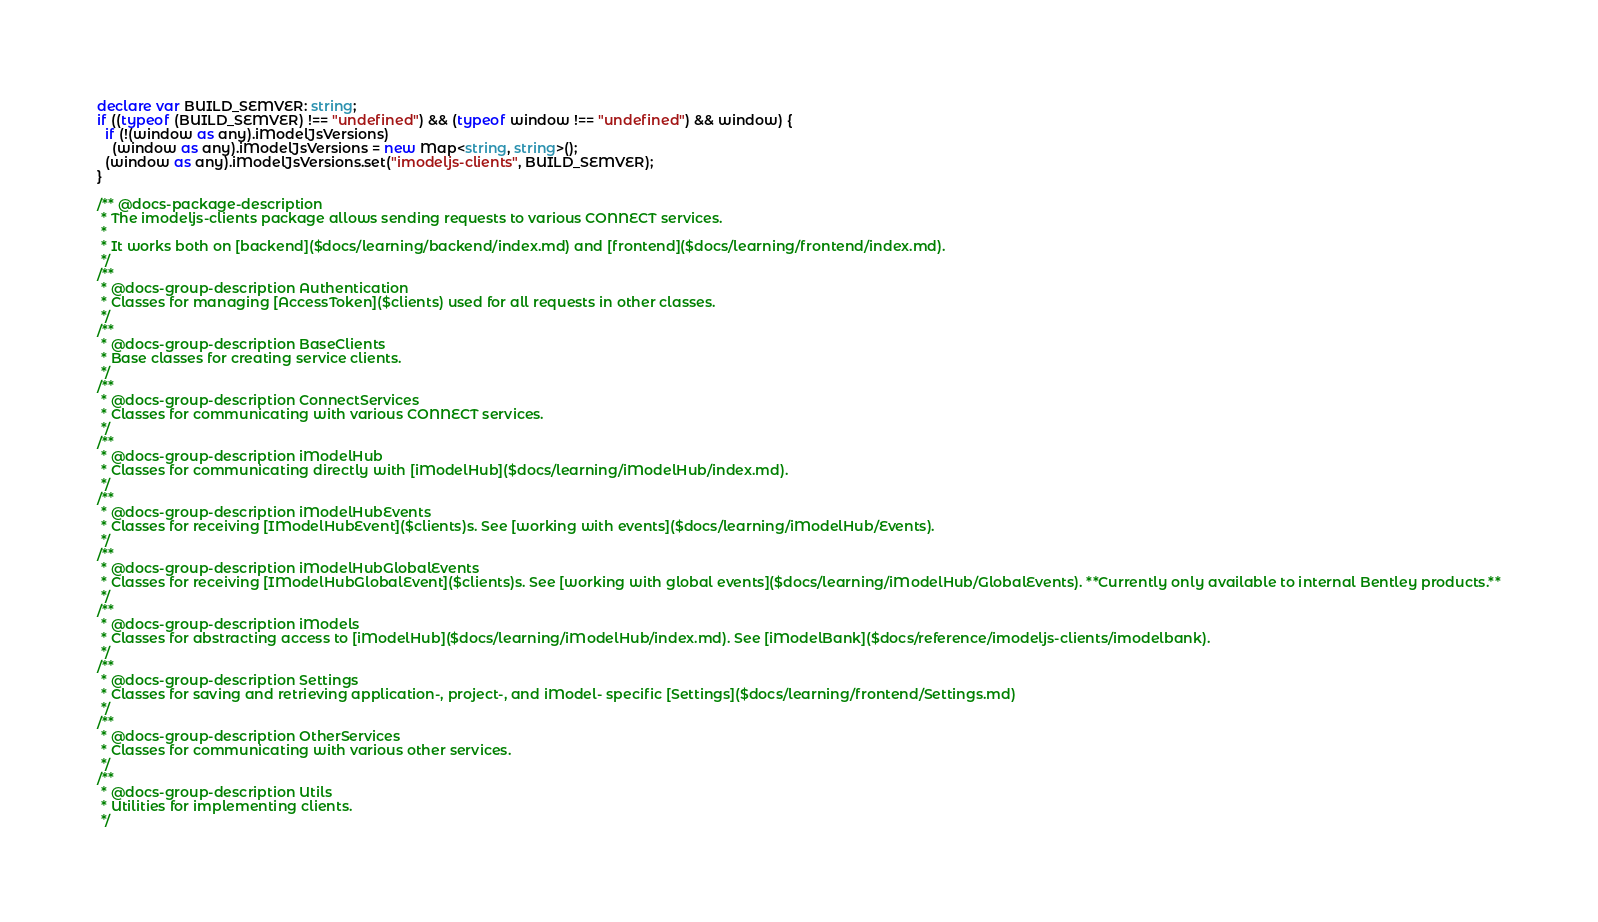<code> <loc_0><loc_0><loc_500><loc_500><_TypeScript_>declare var BUILD_SEMVER: string;
if ((typeof (BUILD_SEMVER) !== "undefined") && (typeof window !== "undefined") && window) {
  if (!(window as any).iModelJsVersions)
    (window as any).iModelJsVersions = new Map<string, string>();
  (window as any).iModelJsVersions.set("imodeljs-clients", BUILD_SEMVER);
}

/** @docs-package-description
 * The imodeljs-clients package allows sending requests to various CONNECT services.
 *
 * It works both on [backend]($docs/learning/backend/index.md) and [frontend]($docs/learning/frontend/index.md).
 */
/**
 * @docs-group-description Authentication
 * Classes for managing [AccessToken]($clients) used for all requests in other classes.
 */
/**
 * @docs-group-description BaseClients
 * Base classes for creating service clients.
 */
/**
 * @docs-group-description ConnectServices
 * Classes for communicating with various CONNECT services.
 */
/**
 * @docs-group-description iModelHub
 * Classes for communicating directly with [iModelHub]($docs/learning/iModelHub/index.md).
 */
/**
 * @docs-group-description iModelHubEvents
 * Classes for receiving [IModelHubEvent]($clients)s. See [working with events]($docs/learning/iModelHub/Events).
 */
/**
 * @docs-group-description iModelHubGlobalEvents
 * Classes for receiving [IModelHubGlobalEvent]($clients)s. See [working with global events]($docs/learning/iModelHub/GlobalEvents). **Currently only available to internal Bentley products.**
 */
/**
 * @docs-group-description iModels
 * Classes for abstracting access to [iModelHub]($docs/learning/iModelHub/index.md). See [iModelBank]($docs/reference/imodeljs-clients/imodelbank).
 */
/**
 * @docs-group-description Settings
 * Classes for saving and retrieving application-, project-, and iModel- specific [Settings]($docs/learning/frontend/Settings.md)
 */
/**
 * @docs-group-description OtherServices
 * Classes for communicating with various other services.
 */
/**
 * @docs-group-description Utils
 * Utilities for implementing clients.
 */
</code> 